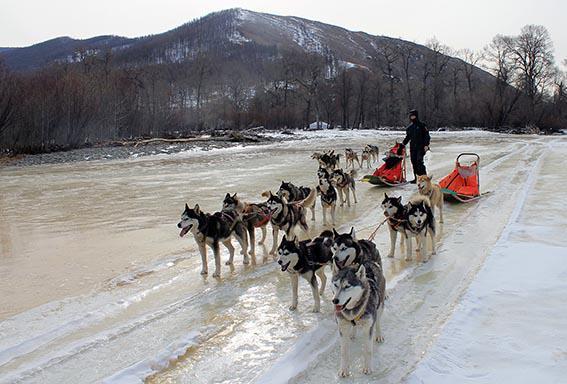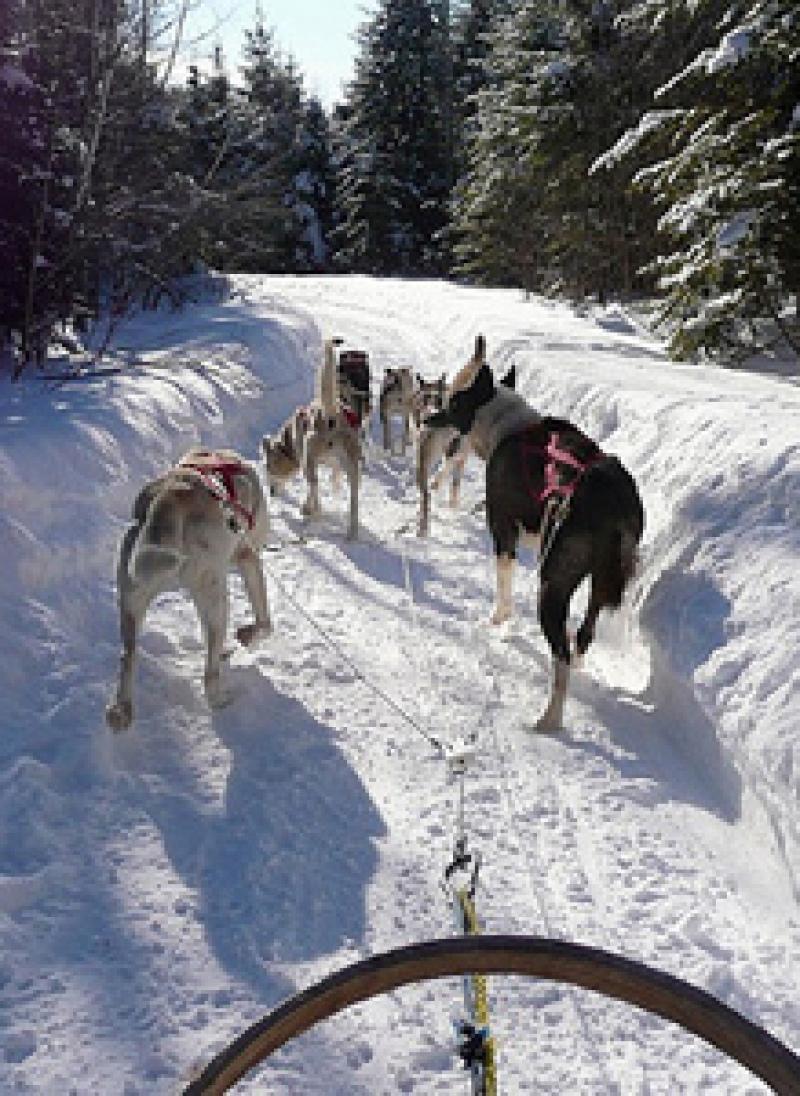The first image is the image on the left, the second image is the image on the right. Considering the images on both sides, is "There are exactly two people in the image on the left." valid? Answer yes or no. No. 